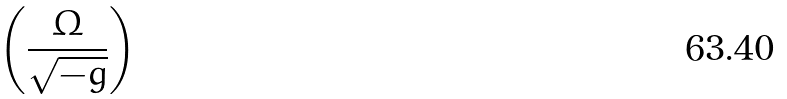<formula> <loc_0><loc_0><loc_500><loc_500>\left ( \frac { \Omega } { \sqrt { - g } } \right )</formula> 